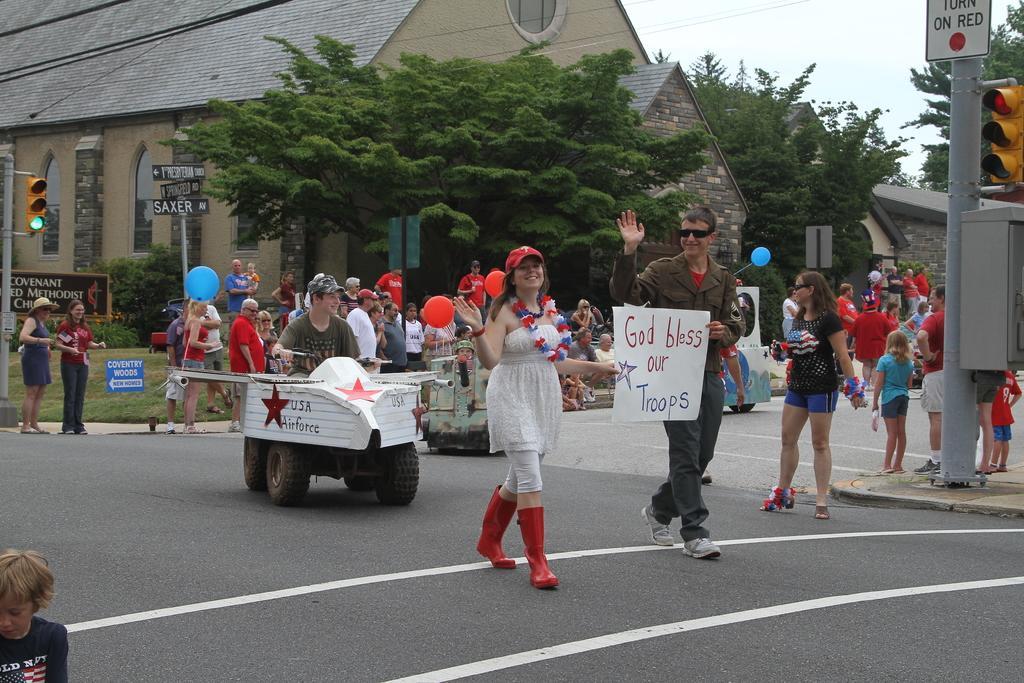Please provide a concise description of this image. In this image we can see many people. Some are wearing caps. And there are balloons. And we can see vehicles on the road. On the right side we can see sign board with a pole. Also there is a box on the pole. In the background there are trees and buildings. Also there is a traffic signal with pole. And there are sign boards on a pole. And we can see man and woman and they are holding paper with text. 